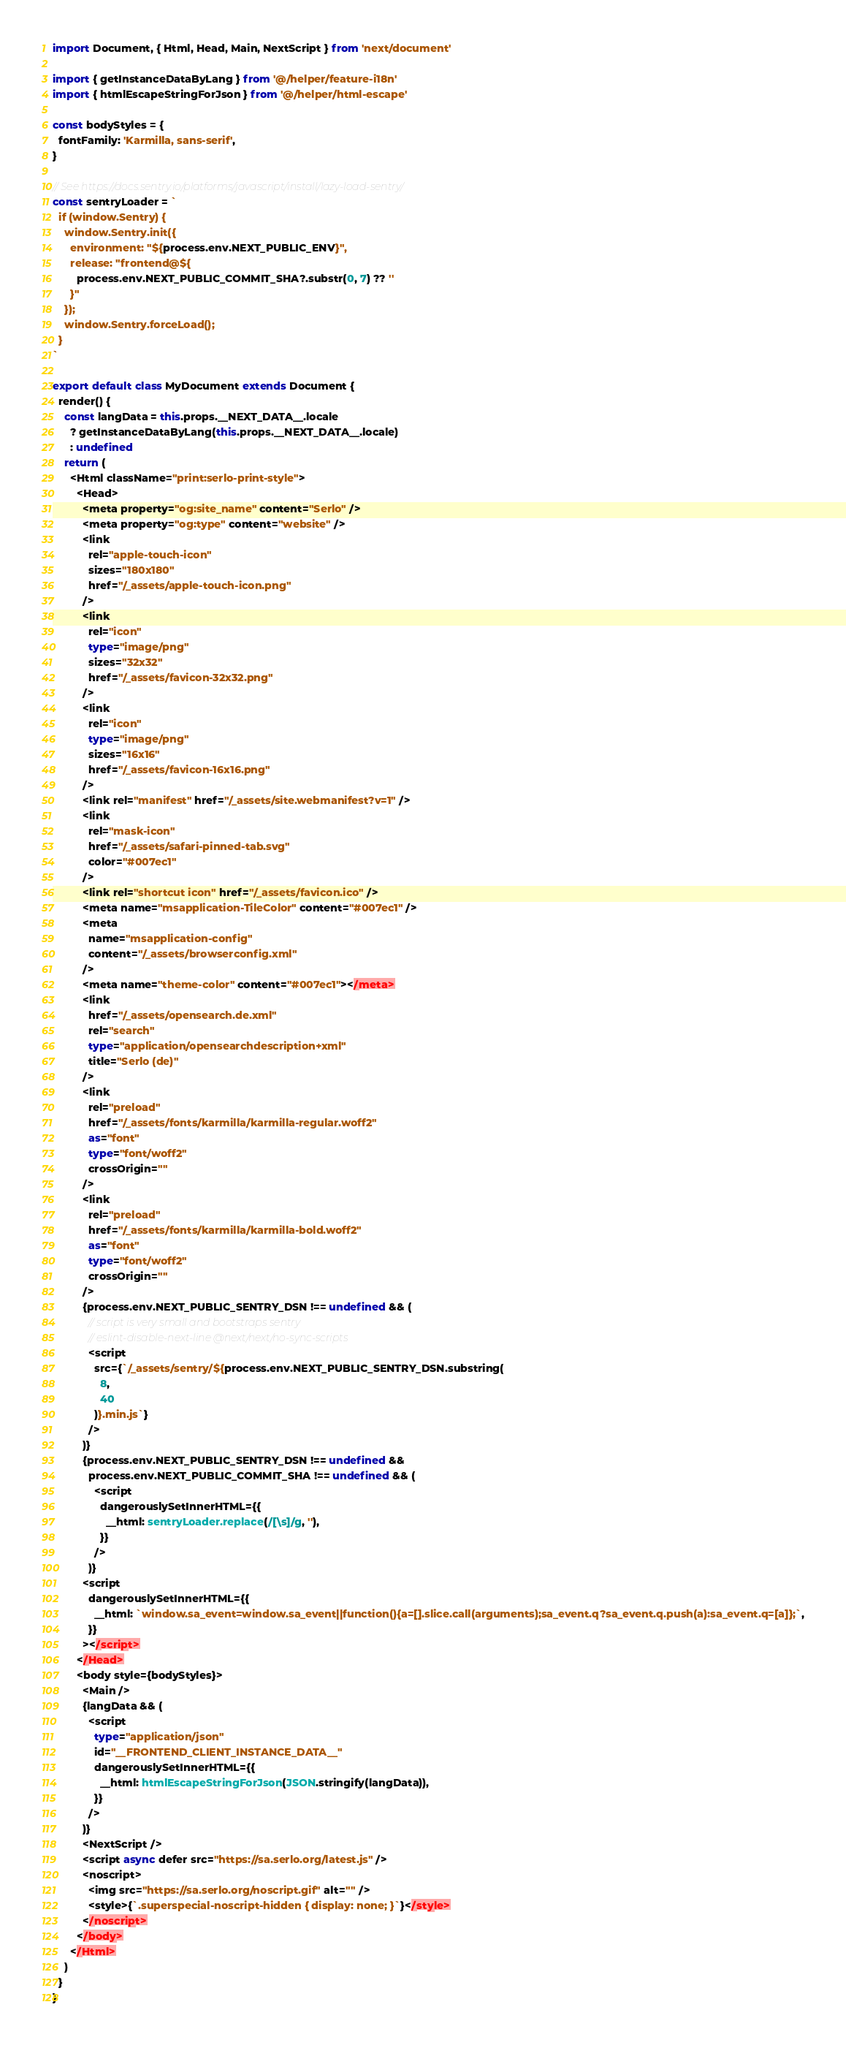Convert code to text. <code><loc_0><loc_0><loc_500><loc_500><_TypeScript_>import Document, { Html, Head, Main, NextScript } from 'next/document'

import { getInstanceDataByLang } from '@/helper/feature-i18n'
import { htmlEscapeStringForJson } from '@/helper/html-escape'

const bodyStyles = {
  fontFamily: 'Karmilla, sans-serif',
}

// See https://docs.sentry.io/platforms/javascript/install/lazy-load-sentry/
const sentryLoader = `
  if (window.Sentry) {
    window.Sentry.init({
      environment: "${process.env.NEXT_PUBLIC_ENV}",
      release: "frontend@${
        process.env.NEXT_PUBLIC_COMMIT_SHA?.substr(0, 7) ?? ''
      }"
    });
    window.Sentry.forceLoad();
  }
`

export default class MyDocument extends Document {
  render() {
    const langData = this.props.__NEXT_DATA__.locale
      ? getInstanceDataByLang(this.props.__NEXT_DATA__.locale)
      : undefined
    return (
      <Html className="print:serlo-print-style">
        <Head>
          <meta property="og:site_name" content="Serlo" />
          <meta property="og:type" content="website" />
          <link
            rel="apple-touch-icon"
            sizes="180x180"
            href="/_assets/apple-touch-icon.png"
          />
          <link
            rel="icon"
            type="image/png"
            sizes="32x32"
            href="/_assets/favicon-32x32.png"
          />
          <link
            rel="icon"
            type="image/png"
            sizes="16x16"
            href="/_assets/favicon-16x16.png"
          />
          <link rel="manifest" href="/_assets/site.webmanifest?v=1" />
          <link
            rel="mask-icon"
            href="/_assets/safari-pinned-tab.svg"
            color="#007ec1"
          />
          <link rel="shortcut icon" href="/_assets/favicon.ico" />
          <meta name="msapplication-TileColor" content="#007ec1" />
          <meta
            name="msapplication-config"
            content="/_assets/browserconfig.xml"
          />
          <meta name="theme-color" content="#007ec1"></meta>
          <link
            href="/_assets/opensearch.de.xml"
            rel="search"
            type="application/opensearchdescription+xml"
            title="Serlo (de)"
          />
          <link
            rel="preload"
            href="/_assets/fonts/karmilla/karmilla-regular.woff2"
            as="font"
            type="font/woff2"
            crossOrigin=""
          />
          <link
            rel="preload"
            href="/_assets/fonts/karmilla/karmilla-bold.woff2"
            as="font"
            type="font/woff2"
            crossOrigin=""
          />
          {process.env.NEXT_PUBLIC_SENTRY_DSN !== undefined && (
            // script is very small and bootstraps sentry
            // eslint-disable-next-line @next/next/no-sync-scripts
            <script
              src={`/_assets/sentry/${process.env.NEXT_PUBLIC_SENTRY_DSN.substring(
                8,
                40
              )}.min.js`}
            />
          )}
          {process.env.NEXT_PUBLIC_SENTRY_DSN !== undefined &&
            process.env.NEXT_PUBLIC_COMMIT_SHA !== undefined && (
              <script
                dangerouslySetInnerHTML={{
                  __html: sentryLoader.replace(/[\s]/g, ''),
                }}
              />
            )}
          <script
            dangerouslySetInnerHTML={{
              __html: `window.sa_event=window.sa_event||function(){a=[].slice.call(arguments);sa_event.q?sa_event.q.push(a):sa_event.q=[a]};`,
            }}
          ></script>
        </Head>
        <body style={bodyStyles}>
          <Main />
          {langData && (
            <script
              type="application/json"
              id="__FRONTEND_CLIENT_INSTANCE_DATA__"
              dangerouslySetInnerHTML={{
                __html: htmlEscapeStringForJson(JSON.stringify(langData)),
              }}
            />
          )}
          <NextScript />
          <script async defer src="https://sa.serlo.org/latest.js" />
          <noscript>
            <img src="https://sa.serlo.org/noscript.gif" alt="" />
            <style>{`.superspecial-noscript-hidden { display: none; }`}</style>
          </noscript>
        </body>
      </Html>
    )
  }
}
</code> 